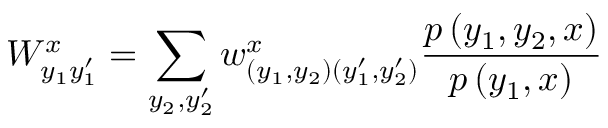<formula> <loc_0><loc_0><loc_500><loc_500>W _ { y _ { 1 } y _ { 1 } ^ { \prime } } ^ { x } = \sum _ { y _ { 2 } , y _ { 2 } ^ { \prime } } w _ { ( y _ { 1 } , y _ { 2 } ) ( y _ { 1 } ^ { \prime } , y _ { 2 } ^ { \prime } ) } ^ { x } \frac { p \left ( y _ { 1 } , y _ { 2 } , x \right ) } { p \left ( y _ { 1 } , x \right ) }</formula> 